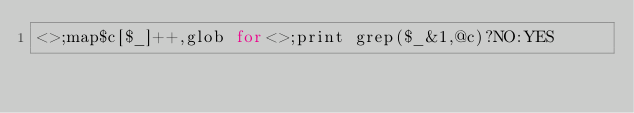<code> <loc_0><loc_0><loc_500><loc_500><_Ruby_><>;map$c[$_]++,glob for<>;print grep($_&1,@c)?NO:YES</code> 